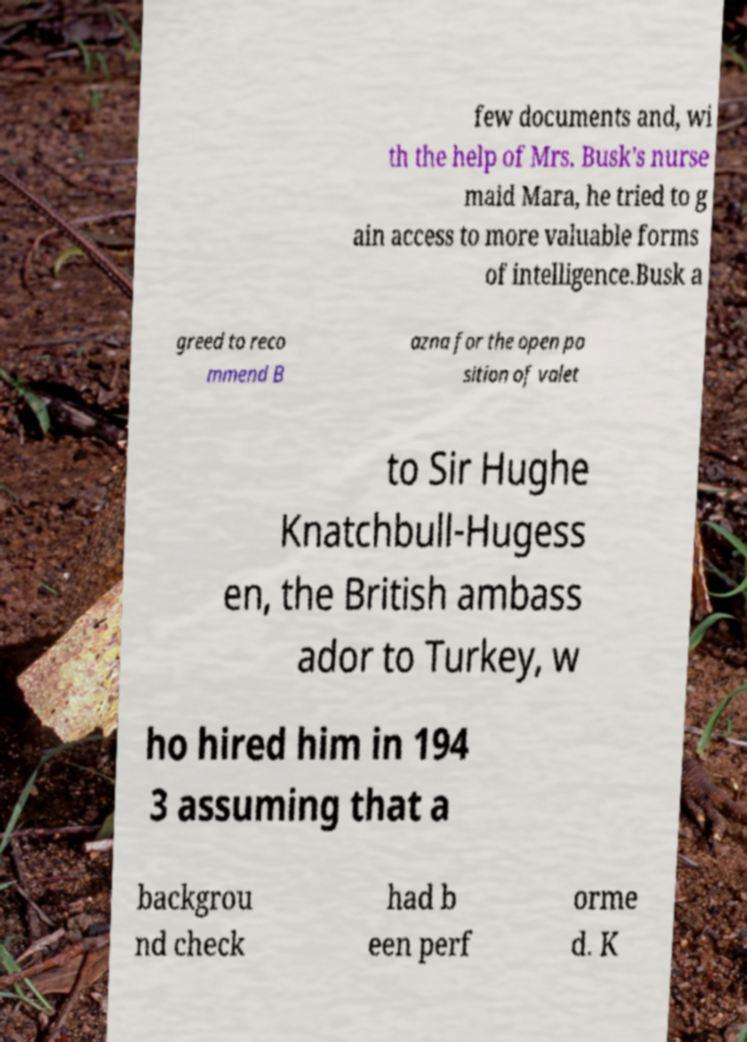Can you read and provide the text displayed in the image?This photo seems to have some interesting text. Can you extract and type it out for me? few documents and, wi th the help of Mrs. Busk's nurse maid Mara, he tried to g ain access to more valuable forms of intelligence.Busk a greed to reco mmend B azna for the open po sition of valet to Sir Hughe Knatchbull-Hugess en, the British ambass ador to Turkey, w ho hired him in 194 3 assuming that a backgrou nd check had b een perf orme d. K 